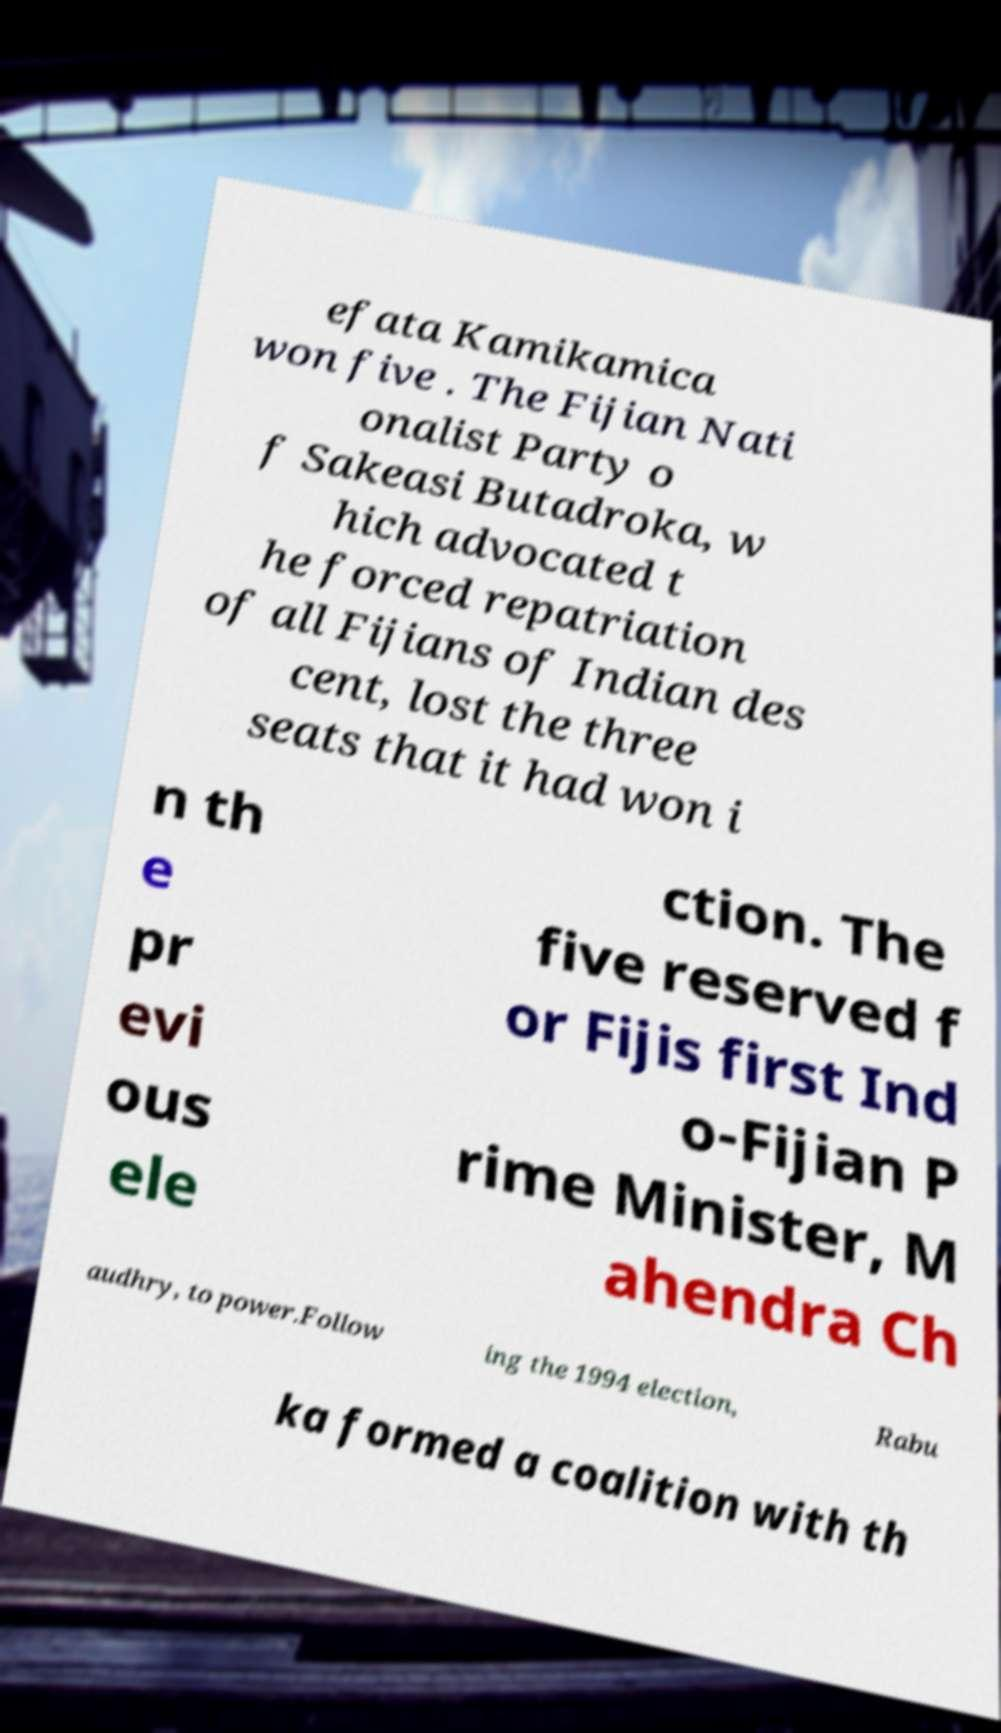What messages or text are displayed in this image? I need them in a readable, typed format. efata Kamikamica won five . The Fijian Nati onalist Party o f Sakeasi Butadroka, w hich advocated t he forced repatriation of all Fijians of Indian des cent, lost the three seats that it had won i n th e pr evi ous ele ction. The five reserved f or Fijis first Ind o-Fijian P rime Minister, M ahendra Ch audhry, to power.Follow ing the 1994 election, Rabu ka formed a coalition with th 